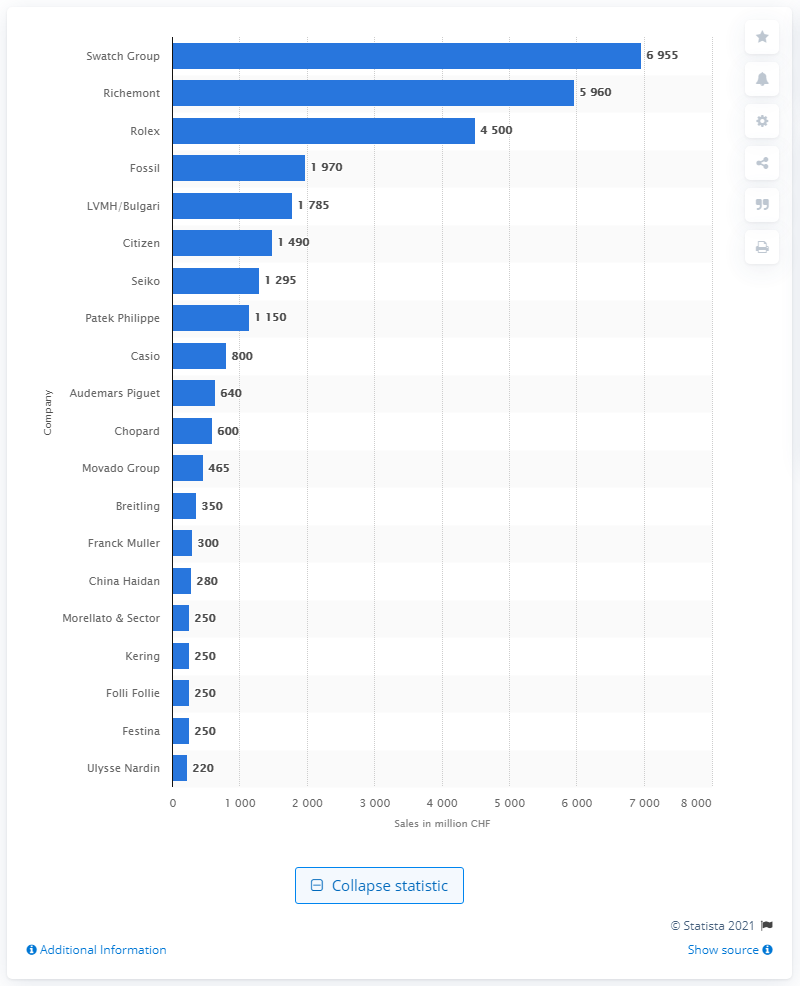Outline some significant characteristics in this image. Rolex is the top brand by a significant margin, making it the clear choice for those seeking the highest quality and prestige in timepieces. In 2015, the most valuable Swiss watch brand was Rolex. 